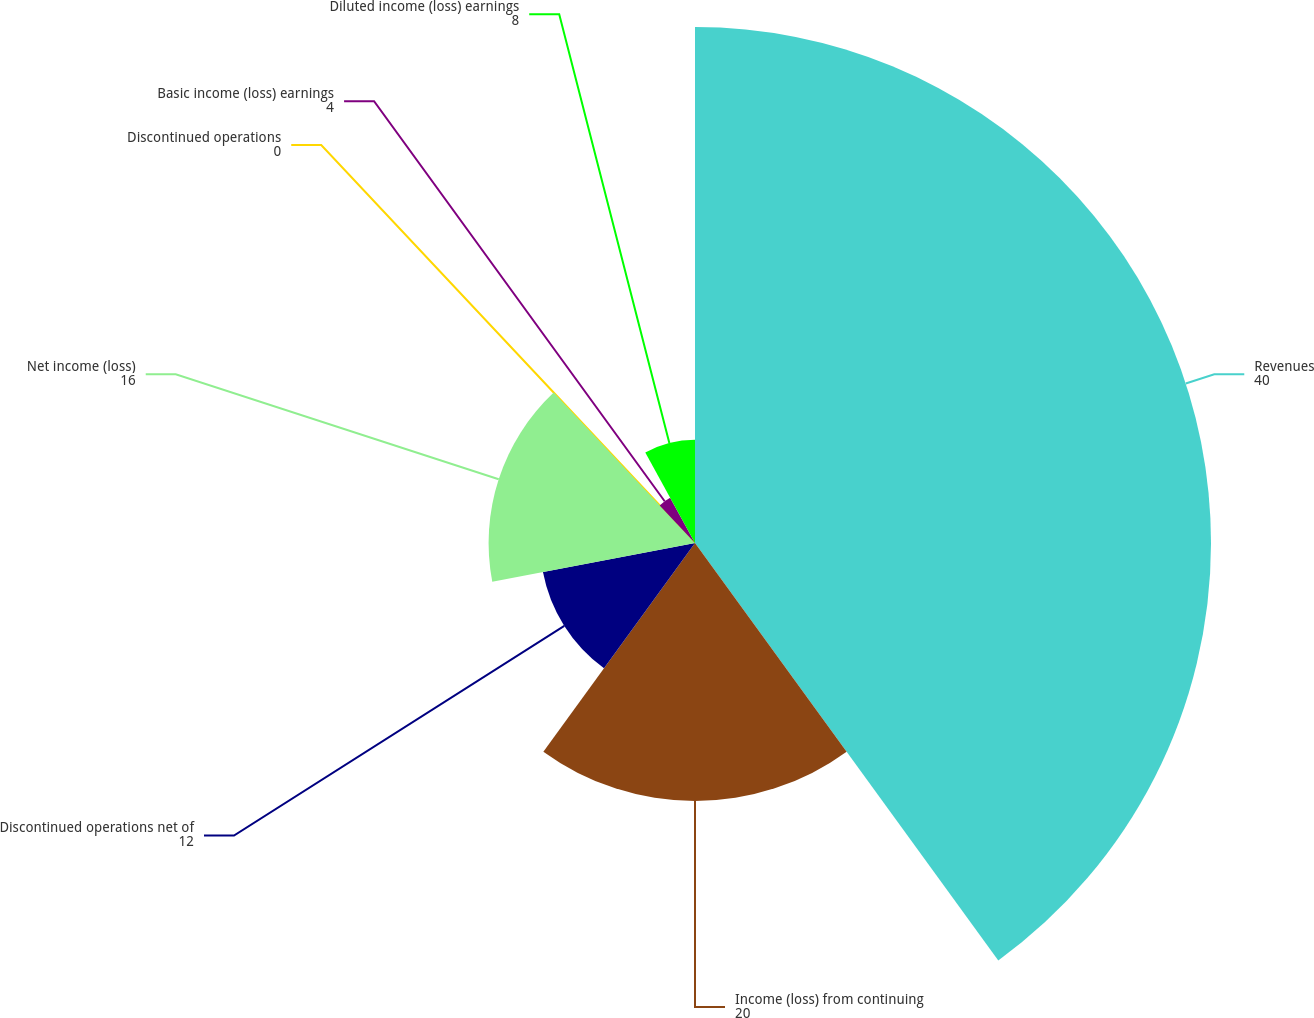Convert chart. <chart><loc_0><loc_0><loc_500><loc_500><pie_chart><fcel>Revenues<fcel>Income (loss) from continuing<fcel>Discontinued operations net of<fcel>Net income (loss)<fcel>Discontinued operations<fcel>Basic income (loss) earnings<fcel>Diluted income (loss) earnings<nl><fcel>40.0%<fcel>20.0%<fcel>12.0%<fcel>16.0%<fcel>0.0%<fcel>4.0%<fcel>8.0%<nl></chart> 